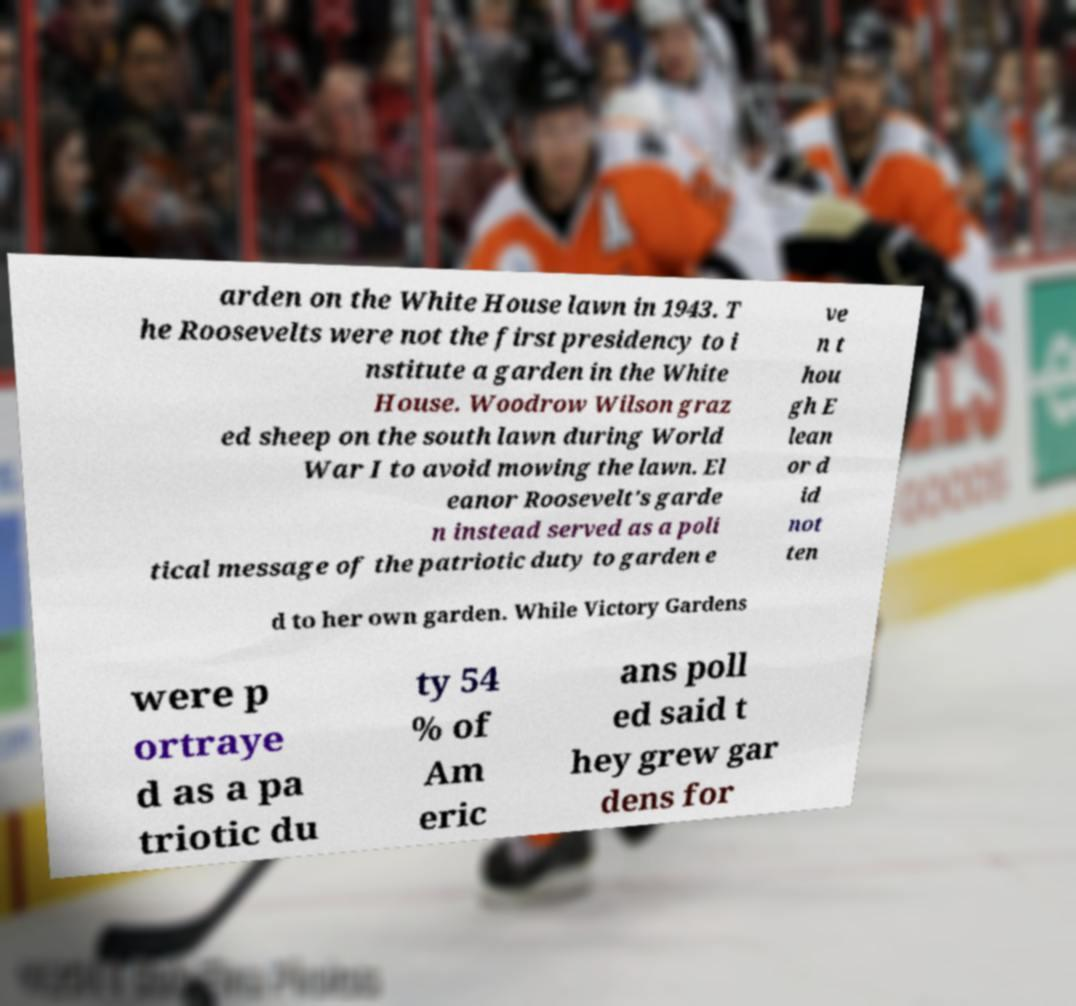What messages or text are displayed in this image? I need them in a readable, typed format. arden on the White House lawn in 1943. T he Roosevelts were not the first presidency to i nstitute a garden in the White House. Woodrow Wilson graz ed sheep on the south lawn during World War I to avoid mowing the lawn. El eanor Roosevelt's garde n instead served as a poli tical message of the patriotic duty to garden e ve n t hou gh E lean or d id not ten d to her own garden. While Victory Gardens were p ortraye d as a pa triotic du ty 54 % of Am eric ans poll ed said t hey grew gar dens for 